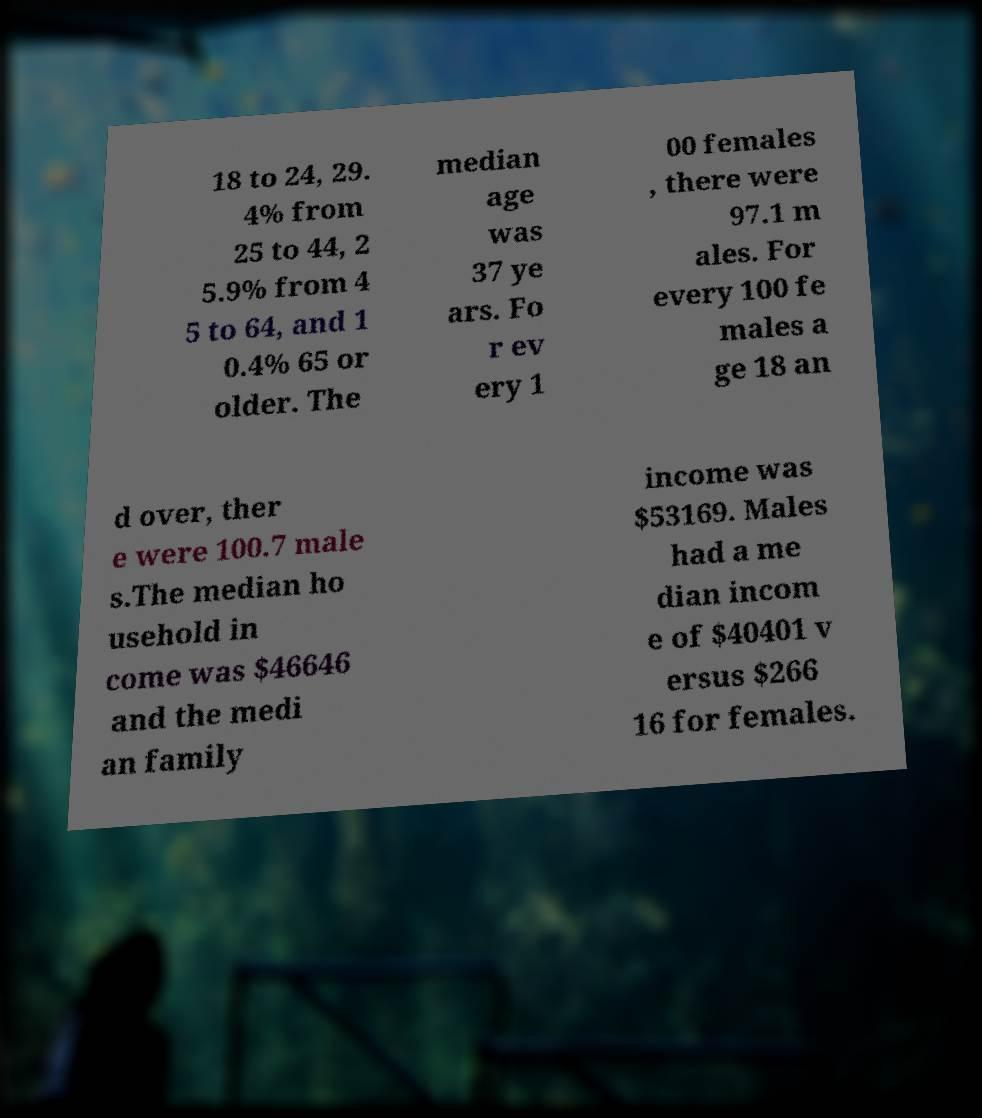Could you assist in decoding the text presented in this image and type it out clearly? 18 to 24, 29. 4% from 25 to 44, 2 5.9% from 4 5 to 64, and 1 0.4% 65 or older. The median age was 37 ye ars. Fo r ev ery 1 00 females , there were 97.1 m ales. For every 100 fe males a ge 18 an d over, ther e were 100.7 male s.The median ho usehold in come was $46646 and the medi an family income was $53169. Males had a me dian incom e of $40401 v ersus $266 16 for females. 